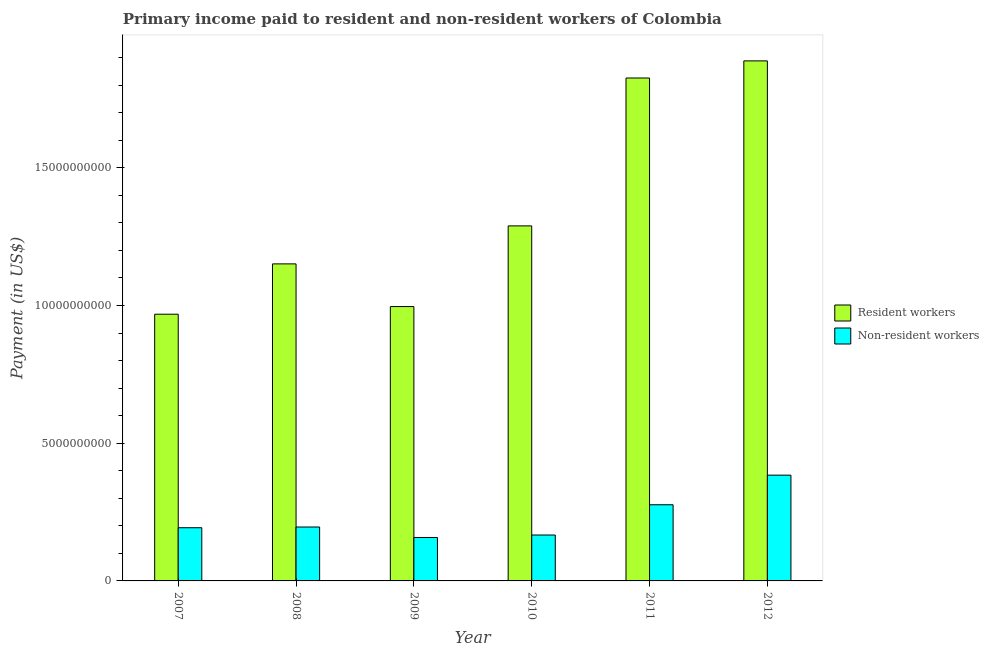Are the number of bars per tick equal to the number of legend labels?
Your answer should be compact. Yes. How many bars are there on the 6th tick from the left?
Your response must be concise. 2. How many bars are there on the 1st tick from the right?
Provide a succinct answer. 2. What is the label of the 1st group of bars from the left?
Give a very brief answer. 2007. In how many cases, is the number of bars for a given year not equal to the number of legend labels?
Offer a very short reply. 0. What is the payment made to resident workers in 2011?
Provide a succinct answer. 1.83e+1. Across all years, what is the maximum payment made to resident workers?
Provide a short and direct response. 1.89e+1. Across all years, what is the minimum payment made to non-resident workers?
Make the answer very short. 1.58e+09. What is the total payment made to non-resident workers in the graph?
Give a very brief answer. 1.37e+1. What is the difference between the payment made to non-resident workers in 2007 and that in 2010?
Your response must be concise. 2.64e+08. What is the difference between the payment made to resident workers in 2008 and the payment made to non-resident workers in 2007?
Your response must be concise. 1.83e+09. What is the average payment made to resident workers per year?
Offer a terse response. 1.35e+1. In the year 2012, what is the difference between the payment made to resident workers and payment made to non-resident workers?
Your answer should be very brief. 0. In how many years, is the payment made to non-resident workers greater than 11000000000 US$?
Give a very brief answer. 0. What is the ratio of the payment made to non-resident workers in 2008 to that in 2011?
Keep it short and to the point. 0.71. What is the difference between the highest and the second highest payment made to resident workers?
Offer a terse response. 6.22e+08. What is the difference between the highest and the lowest payment made to non-resident workers?
Your answer should be compact. 2.26e+09. What does the 1st bar from the left in 2012 represents?
Your answer should be very brief. Resident workers. What does the 1st bar from the right in 2010 represents?
Keep it short and to the point. Non-resident workers. Are all the bars in the graph horizontal?
Provide a succinct answer. No. How many years are there in the graph?
Make the answer very short. 6. Are the values on the major ticks of Y-axis written in scientific E-notation?
Your answer should be compact. No. Does the graph contain any zero values?
Keep it short and to the point. No. Does the graph contain grids?
Keep it short and to the point. No. How many legend labels are there?
Your response must be concise. 2. How are the legend labels stacked?
Make the answer very short. Vertical. What is the title of the graph?
Ensure brevity in your answer.  Primary income paid to resident and non-resident workers of Colombia. What is the label or title of the Y-axis?
Keep it short and to the point. Payment (in US$). What is the Payment (in US$) of Resident workers in 2007?
Your response must be concise. 9.68e+09. What is the Payment (in US$) of Non-resident workers in 2007?
Give a very brief answer. 1.93e+09. What is the Payment (in US$) of Resident workers in 2008?
Give a very brief answer. 1.15e+1. What is the Payment (in US$) in Non-resident workers in 2008?
Your answer should be very brief. 1.96e+09. What is the Payment (in US$) of Resident workers in 2009?
Your response must be concise. 9.96e+09. What is the Payment (in US$) in Non-resident workers in 2009?
Your answer should be compact. 1.58e+09. What is the Payment (in US$) of Resident workers in 2010?
Your answer should be compact. 1.29e+1. What is the Payment (in US$) in Non-resident workers in 2010?
Offer a terse response. 1.67e+09. What is the Payment (in US$) of Resident workers in 2011?
Your answer should be compact. 1.83e+1. What is the Payment (in US$) in Non-resident workers in 2011?
Your answer should be compact. 2.77e+09. What is the Payment (in US$) in Resident workers in 2012?
Your response must be concise. 1.89e+1. What is the Payment (in US$) in Non-resident workers in 2012?
Your response must be concise. 3.84e+09. Across all years, what is the maximum Payment (in US$) of Resident workers?
Keep it short and to the point. 1.89e+1. Across all years, what is the maximum Payment (in US$) in Non-resident workers?
Provide a short and direct response. 3.84e+09. Across all years, what is the minimum Payment (in US$) in Resident workers?
Provide a succinct answer. 9.68e+09. Across all years, what is the minimum Payment (in US$) of Non-resident workers?
Give a very brief answer. 1.58e+09. What is the total Payment (in US$) in Resident workers in the graph?
Ensure brevity in your answer.  8.12e+1. What is the total Payment (in US$) of Non-resident workers in the graph?
Give a very brief answer. 1.37e+1. What is the difference between the Payment (in US$) of Resident workers in 2007 and that in 2008?
Your answer should be very brief. -1.83e+09. What is the difference between the Payment (in US$) of Non-resident workers in 2007 and that in 2008?
Keep it short and to the point. -2.61e+07. What is the difference between the Payment (in US$) in Resident workers in 2007 and that in 2009?
Your answer should be compact. -2.78e+08. What is the difference between the Payment (in US$) in Non-resident workers in 2007 and that in 2009?
Your answer should be compact. 3.54e+08. What is the difference between the Payment (in US$) of Resident workers in 2007 and that in 2010?
Your answer should be compact. -3.21e+09. What is the difference between the Payment (in US$) of Non-resident workers in 2007 and that in 2010?
Your response must be concise. 2.64e+08. What is the difference between the Payment (in US$) in Resident workers in 2007 and that in 2011?
Offer a terse response. -8.58e+09. What is the difference between the Payment (in US$) in Non-resident workers in 2007 and that in 2011?
Your answer should be compact. -8.34e+08. What is the difference between the Payment (in US$) of Resident workers in 2007 and that in 2012?
Offer a very short reply. -9.20e+09. What is the difference between the Payment (in US$) of Non-resident workers in 2007 and that in 2012?
Make the answer very short. -1.91e+09. What is the difference between the Payment (in US$) of Resident workers in 2008 and that in 2009?
Your answer should be very brief. 1.55e+09. What is the difference between the Payment (in US$) of Non-resident workers in 2008 and that in 2009?
Provide a succinct answer. 3.80e+08. What is the difference between the Payment (in US$) of Resident workers in 2008 and that in 2010?
Your response must be concise. -1.38e+09. What is the difference between the Payment (in US$) of Non-resident workers in 2008 and that in 2010?
Make the answer very short. 2.90e+08. What is the difference between the Payment (in US$) of Resident workers in 2008 and that in 2011?
Your response must be concise. -6.75e+09. What is the difference between the Payment (in US$) of Non-resident workers in 2008 and that in 2011?
Give a very brief answer. -8.08e+08. What is the difference between the Payment (in US$) of Resident workers in 2008 and that in 2012?
Your answer should be compact. -7.37e+09. What is the difference between the Payment (in US$) of Non-resident workers in 2008 and that in 2012?
Your answer should be very brief. -1.88e+09. What is the difference between the Payment (in US$) in Resident workers in 2009 and that in 2010?
Provide a short and direct response. -2.93e+09. What is the difference between the Payment (in US$) of Non-resident workers in 2009 and that in 2010?
Provide a short and direct response. -8.95e+07. What is the difference between the Payment (in US$) in Resident workers in 2009 and that in 2011?
Your answer should be compact. -8.30e+09. What is the difference between the Payment (in US$) in Non-resident workers in 2009 and that in 2011?
Offer a terse response. -1.19e+09. What is the difference between the Payment (in US$) of Resident workers in 2009 and that in 2012?
Offer a very short reply. -8.92e+09. What is the difference between the Payment (in US$) of Non-resident workers in 2009 and that in 2012?
Your response must be concise. -2.26e+09. What is the difference between the Payment (in US$) of Resident workers in 2010 and that in 2011?
Offer a terse response. -5.37e+09. What is the difference between the Payment (in US$) in Non-resident workers in 2010 and that in 2011?
Keep it short and to the point. -1.10e+09. What is the difference between the Payment (in US$) in Resident workers in 2010 and that in 2012?
Give a very brief answer. -5.99e+09. What is the difference between the Payment (in US$) of Non-resident workers in 2010 and that in 2012?
Your answer should be compact. -2.17e+09. What is the difference between the Payment (in US$) in Resident workers in 2011 and that in 2012?
Keep it short and to the point. -6.22e+08. What is the difference between the Payment (in US$) of Non-resident workers in 2011 and that in 2012?
Provide a short and direct response. -1.07e+09. What is the difference between the Payment (in US$) in Resident workers in 2007 and the Payment (in US$) in Non-resident workers in 2008?
Provide a short and direct response. 7.73e+09. What is the difference between the Payment (in US$) of Resident workers in 2007 and the Payment (in US$) of Non-resident workers in 2009?
Your answer should be compact. 8.11e+09. What is the difference between the Payment (in US$) in Resident workers in 2007 and the Payment (in US$) in Non-resident workers in 2010?
Your response must be concise. 8.02e+09. What is the difference between the Payment (in US$) in Resident workers in 2007 and the Payment (in US$) in Non-resident workers in 2011?
Keep it short and to the point. 6.92e+09. What is the difference between the Payment (in US$) in Resident workers in 2007 and the Payment (in US$) in Non-resident workers in 2012?
Provide a short and direct response. 5.84e+09. What is the difference between the Payment (in US$) in Resident workers in 2008 and the Payment (in US$) in Non-resident workers in 2009?
Ensure brevity in your answer.  9.93e+09. What is the difference between the Payment (in US$) of Resident workers in 2008 and the Payment (in US$) of Non-resident workers in 2010?
Offer a very short reply. 9.84e+09. What is the difference between the Payment (in US$) in Resident workers in 2008 and the Payment (in US$) in Non-resident workers in 2011?
Your response must be concise. 8.75e+09. What is the difference between the Payment (in US$) in Resident workers in 2008 and the Payment (in US$) in Non-resident workers in 2012?
Ensure brevity in your answer.  7.67e+09. What is the difference between the Payment (in US$) in Resident workers in 2009 and the Payment (in US$) in Non-resident workers in 2010?
Give a very brief answer. 8.29e+09. What is the difference between the Payment (in US$) of Resident workers in 2009 and the Payment (in US$) of Non-resident workers in 2011?
Offer a very short reply. 7.20e+09. What is the difference between the Payment (in US$) of Resident workers in 2009 and the Payment (in US$) of Non-resident workers in 2012?
Keep it short and to the point. 6.12e+09. What is the difference between the Payment (in US$) in Resident workers in 2010 and the Payment (in US$) in Non-resident workers in 2011?
Provide a short and direct response. 1.01e+1. What is the difference between the Payment (in US$) of Resident workers in 2010 and the Payment (in US$) of Non-resident workers in 2012?
Offer a terse response. 9.05e+09. What is the difference between the Payment (in US$) in Resident workers in 2011 and the Payment (in US$) in Non-resident workers in 2012?
Offer a terse response. 1.44e+1. What is the average Payment (in US$) of Resident workers per year?
Offer a very short reply. 1.35e+1. What is the average Payment (in US$) of Non-resident workers per year?
Keep it short and to the point. 2.29e+09. In the year 2007, what is the difference between the Payment (in US$) in Resident workers and Payment (in US$) in Non-resident workers?
Provide a succinct answer. 7.75e+09. In the year 2008, what is the difference between the Payment (in US$) of Resident workers and Payment (in US$) of Non-resident workers?
Provide a short and direct response. 9.55e+09. In the year 2009, what is the difference between the Payment (in US$) of Resident workers and Payment (in US$) of Non-resident workers?
Give a very brief answer. 8.38e+09. In the year 2010, what is the difference between the Payment (in US$) in Resident workers and Payment (in US$) in Non-resident workers?
Give a very brief answer. 1.12e+1. In the year 2011, what is the difference between the Payment (in US$) of Resident workers and Payment (in US$) of Non-resident workers?
Make the answer very short. 1.55e+1. In the year 2012, what is the difference between the Payment (in US$) of Resident workers and Payment (in US$) of Non-resident workers?
Provide a short and direct response. 1.50e+1. What is the ratio of the Payment (in US$) in Resident workers in 2007 to that in 2008?
Make the answer very short. 0.84. What is the ratio of the Payment (in US$) of Non-resident workers in 2007 to that in 2008?
Offer a very short reply. 0.99. What is the ratio of the Payment (in US$) in Resident workers in 2007 to that in 2009?
Your answer should be very brief. 0.97. What is the ratio of the Payment (in US$) in Non-resident workers in 2007 to that in 2009?
Offer a very short reply. 1.22. What is the ratio of the Payment (in US$) in Resident workers in 2007 to that in 2010?
Ensure brevity in your answer.  0.75. What is the ratio of the Payment (in US$) of Non-resident workers in 2007 to that in 2010?
Offer a terse response. 1.16. What is the ratio of the Payment (in US$) of Resident workers in 2007 to that in 2011?
Give a very brief answer. 0.53. What is the ratio of the Payment (in US$) of Non-resident workers in 2007 to that in 2011?
Your answer should be compact. 0.7. What is the ratio of the Payment (in US$) of Resident workers in 2007 to that in 2012?
Offer a terse response. 0.51. What is the ratio of the Payment (in US$) of Non-resident workers in 2007 to that in 2012?
Your response must be concise. 0.5. What is the ratio of the Payment (in US$) of Resident workers in 2008 to that in 2009?
Ensure brevity in your answer.  1.16. What is the ratio of the Payment (in US$) of Non-resident workers in 2008 to that in 2009?
Provide a succinct answer. 1.24. What is the ratio of the Payment (in US$) of Resident workers in 2008 to that in 2010?
Offer a terse response. 0.89. What is the ratio of the Payment (in US$) in Non-resident workers in 2008 to that in 2010?
Give a very brief answer. 1.17. What is the ratio of the Payment (in US$) of Resident workers in 2008 to that in 2011?
Ensure brevity in your answer.  0.63. What is the ratio of the Payment (in US$) of Non-resident workers in 2008 to that in 2011?
Make the answer very short. 0.71. What is the ratio of the Payment (in US$) of Resident workers in 2008 to that in 2012?
Provide a short and direct response. 0.61. What is the ratio of the Payment (in US$) in Non-resident workers in 2008 to that in 2012?
Keep it short and to the point. 0.51. What is the ratio of the Payment (in US$) in Resident workers in 2009 to that in 2010?
Provide a succinct answer. 0.77. What is the ratio of the Payment (in US$) of Non-resident workers in 2009 to that in 2010?
Offer a terse response. 0.95. What is the ratio of the Payment (in US$) of Resident workers in 2009 to that in 2011?
Your answer should be compact. 0.55. What is the ratio of the Payment (in US$) in Non-resident workers in 2009 to that in 2011?
Make the answer very short. 0.57. What is the ratio of the Payment (in US$) in Resident workers in 2009 to that in 2012?
Your response must be concise. 0.53. What is the ratio of the Payment (in US$) of Non-resident workers in 2009 to that in 2012?
Your answer should be very brief. 0.41. What is the ratio of the Payment (in US$) of Resident workers in 2010 to that in 2011?
Ensure brevity in your answer.  0.71. What is the ratio of the Payment (in US$) in Non-resident workers in 2010 to that in 2011?
Offer a very short reply. 0.6. What is the ratio of the Payment (in US$) in Resident workers in 2010 to that in 2012?
Offer a very short reply. 0.68. What is the ratio of the Payment (in US$) of Non-resident workers in 2010 to that in 2012?
Keep it short and to the point. 0.43. What is the ratio of the Payment (in US$) of Resident workers in 2011 to that in 2012?
Your answer should be very brief. 0.97. What is the ratio of the Payment (in US$) in Non-resident workers in 2011 to that in 2012?
Your response must be concise. 0.72. What is the difference between the highest and the second highest Payment (in US$) in Resident workers?
Give a very brief answer. 6.22e+08. What is the difference between the highest and the second highest Payment (in US$) in Non-resident workers?
Ensure brevity in your answer.  1.07e+09. What is the difference between the highest and the lowest Payment (in US$) in Resident workers?
Keep it short and to the point. 9.20e+09. What is the difference between the highest and the lowest Payment (in US$) in Non-resident workers?
Provide a short and direct response. 2.26e+09. 